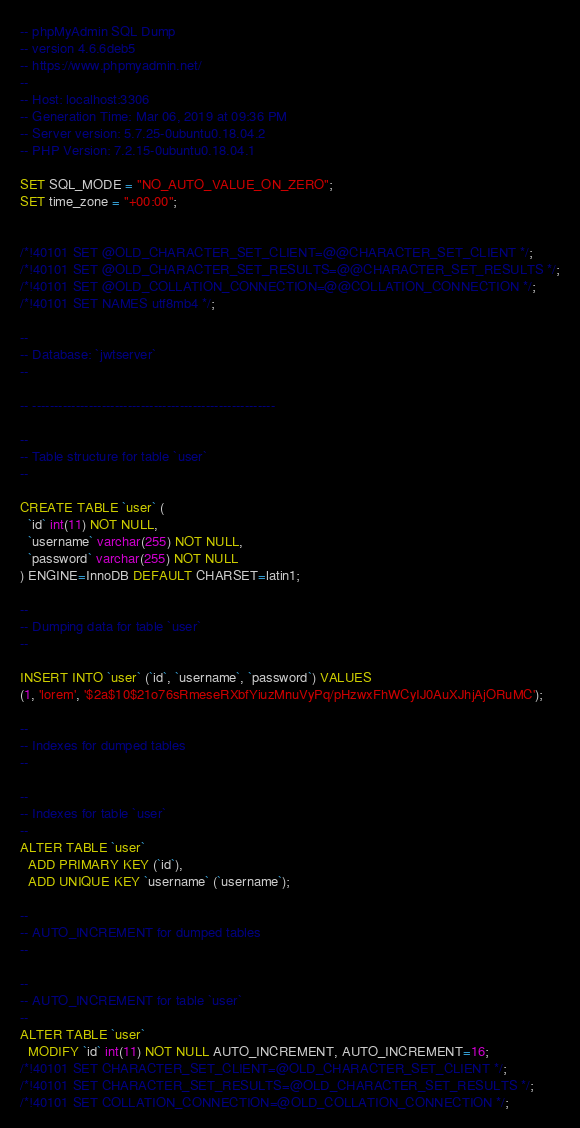<code> <loc_0><loc_0><loc_500><loc_500><_SQL_>-- phpMyAdmin SQL Dump
-- version 4.6.6deb5
-- https://www.phpmyadmin.net/
--
-- Host: localhost:3306
-- Generation Time: Mar 06, 2019 at 09:36 PM
-- Server version: 5.7.25-0ubuntu0.18.04.2
-- PHP Version: 7.2.15-0ubuntu0.18.04.1

SET SQL_MODE = "NO_AUTO_VALUE_ON_ZERO";
SET time_zone = "+00:00";


/*!40101 SET @OLD_CHARACTER_SET_CLIENT=@@CHARACTER_SET_CLIENT */;
/*!40101 SET @OLD_CHARACTER_SET_RESULTS=@@CHARACTER_SET_RESULTS */;
/*!40101 SET @OLD_COLLATION_CONNECTION=@@COLLATION_CONNECTION */;
/*!40101 SET NAMES utf8mb4 */;

--
-- Database: `jwtserver`
--

-- --------------------------------------------------------

--
-- Table structure for table `user`
--

CREATE TABLE `user` (
  `id` int(11) NOT NULL,
  `username` varchar(255) NOT NULL,
  `password` varchar(255) NOT NULL
) ENGINE=InnoDB DEFAULT CHARSET=latin1;

--
-- Dumping data for table `user`
--

INSERT INTO `user` (`id`, `username`, `password`) VALUES
(1, 'lorem', '$2a$10$21o76sRmeseRXbfYiuzMnuVyPq/pHzwxFhWCyIJ0AuXJhjAjORuMC');

--
-- Indexes for dumped tables
--

--
-- Indexes for table `user`
--
ALTER TABLE `user`
  ADD PRIMARY KEY (`id`),
  ADD UNIQUE KEY `username` (`username`);

--
-- AUTO_INCREMENT for dumped tables
--

--
-- AUTO_INCREMENT for table `user`
--
ALTER TABLE `user`
  MODIFY `id` int(11) NOT NULL AUTO_INCREMENT, AUTO_INCREMENT=16;
/*!40101 SET CHARACTER_SET_CLIENT=@OLD_CHARACTER_SET_CLIENT */;
/*!40101 SET CHARACTER_SET_RESULTS=@OLD_CHARACTER_SET_RESULTS */;
/*!40101 SET COLLATION_CONNECTION=@OLD_COLLATION_CONNECTION */;
</code> 